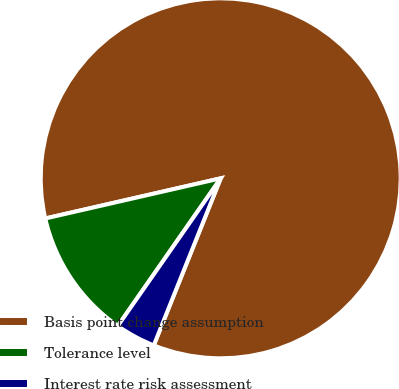Convert chart. <chart><loc_0><loc_0><loc_500><loc_500><pie_chart><fcel>Basis point change assumption<fcel>Tolerance level<fcel>Interest rate risk assessment<nl><fcel>84.65%<fcel>11.73%<fcel>3.62%<nl></chart> 